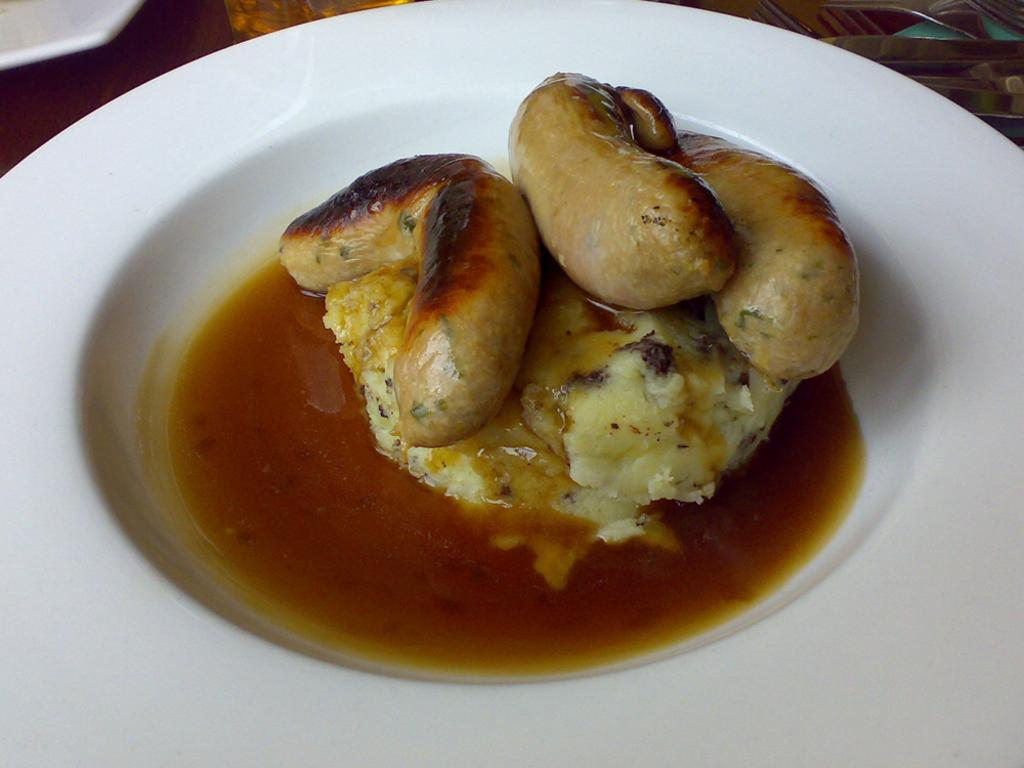What is the main subject of the image? There is an edible in the image. Can you describe the type of food in the image? There is a soup in the image. What is the color of the plate on which the food is placed? Both the edible and the soup are placed on a white plate. Can you tell me how many dogs are present in the image? There are no dogs present in the image. What type of bag is visible in the image? There is no bag present in the image. 